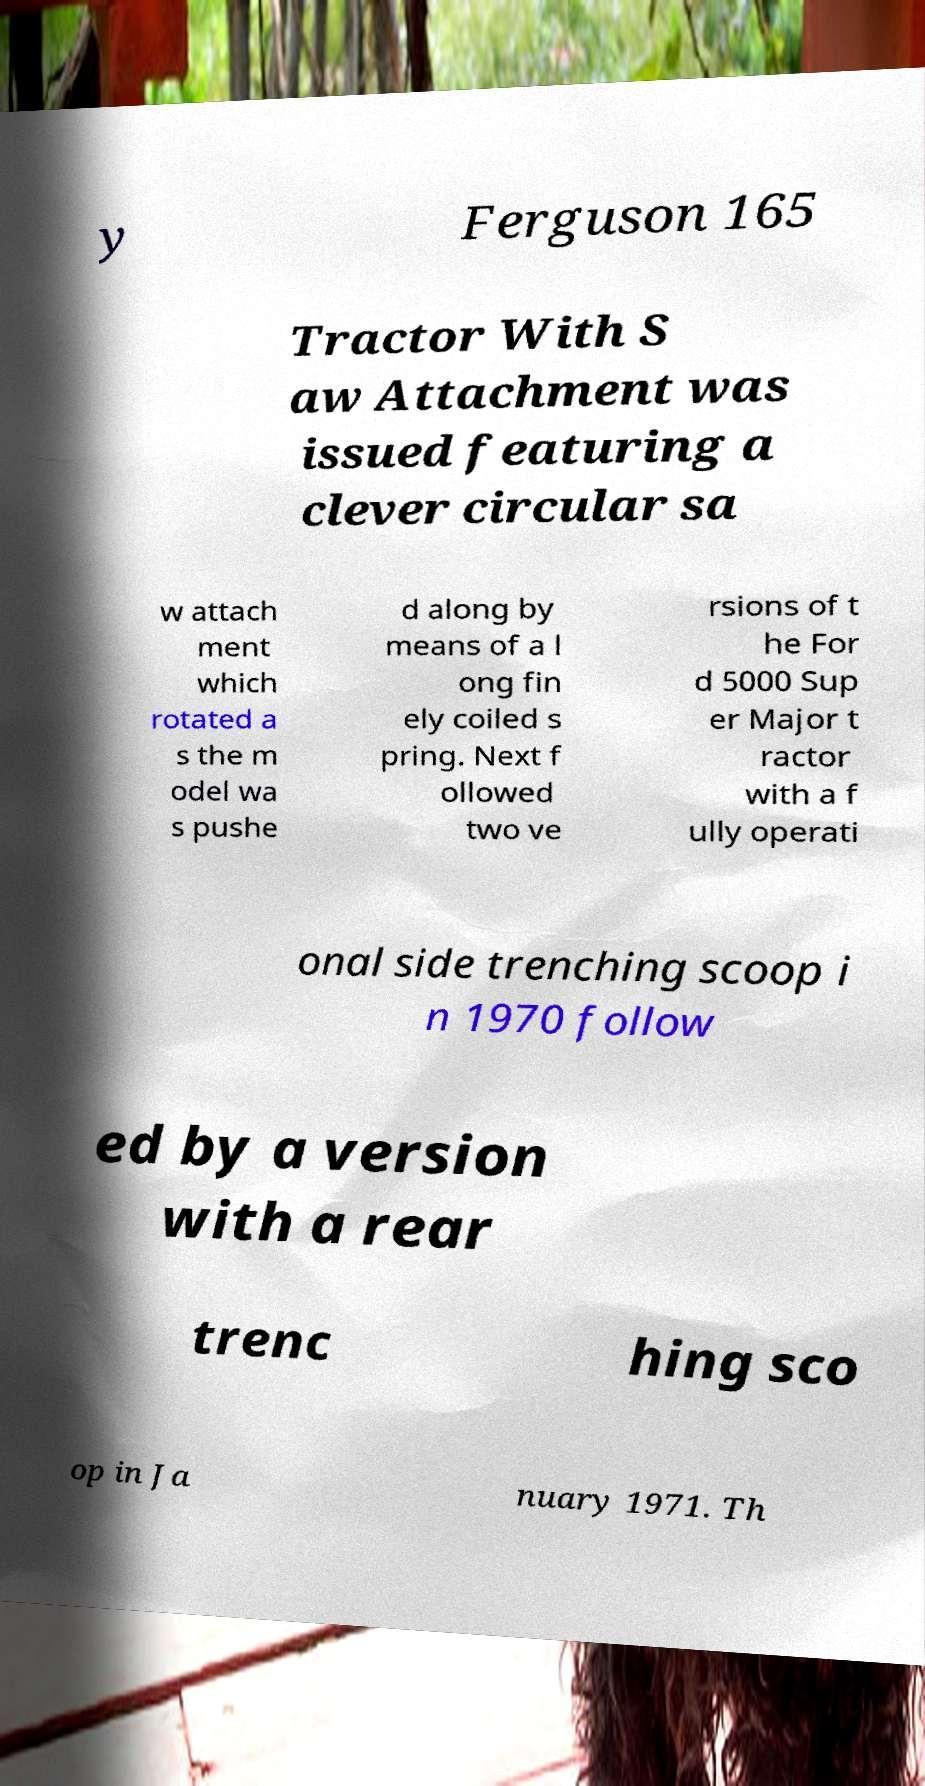Can you accurately transcribe the text from the provided image for me? y Ferguson 165 Tractor With S aw Attachment was issued featuring a clever circular sa w attach ment which rotated a s the m odel wa s pushe d along by means of a l ong fin ely coiled s pring. Next f ollowed two ve rsions of t he For d 5000 Sup er Major t ractor with a f ully operati onal side trenching scoop i n 1970 follow ed by a version with a rear trenc hing sco op in Ja nuary 1971. Th 